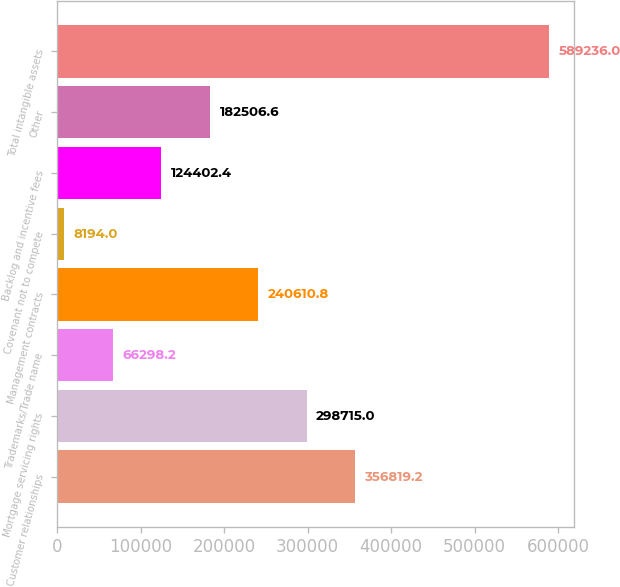Convert chart. <chart><loc_0><loc_0><loc_500><loc_500><bar_chart><fcel>Customer relationships<fcel>Mortgage servicing rights<fcel>Trademarks/Trade name<fcel>Management contracts<fcel>Covenant not to compete<fcel>Backlog and incentive fees<fcel>Other<fcel>Total intangible assets<nl><fcel>356819<fcel>298715<fcel>66298.2<fcel>240611<fcel>8194<fcel>124402<fcel>182507<fcel>589236<nl></chart> 